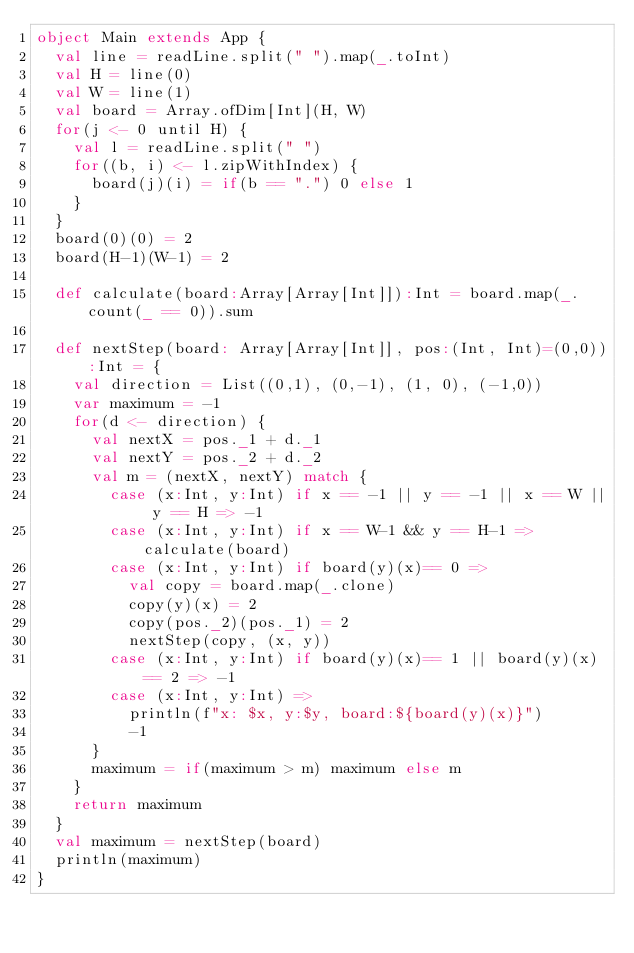<code> <loc_0><loc_0><loc_500><loc_500><_Scala_>object Main extends App {
  val line = readLine.split(" ").map(_.toInt)
  val H = line(0)
  val W = line(1)
  val board = Array.ofDim[Int](H, W)
  for(j <- 0 until H) {
    val l = readLine.split(" ")
    for((b, i) <- l.zipWithIndex) {
      board(j)(i) = if(b == ".") 0 else 1
    }
  }
  board(0)(0) = 2
  board(H-1)(W-1) = 2

  def calculate(board:Array[Array[Int]]):Int = board.map(_.count(_ == 0)).sum

  def nextStep(board: Array[Array[Int]], pos:(Int, Int)=(0,0)):Int = {
    val direction = List((0,1), (0,-1), (1, 0), (-1,0))
    var maximum = -1
    for(d <- direction) {
      val nextX = pos._1 + d._1
      val nextY = pos._2 + d._2
      val m = (nextX, nextY) match {
        case (x:Int, y:Int) if x == -1 || y == -1 || x == W || y == H => -1
        case (x:Int, y:Int) if x == W-1 && y == H-1 => calculate(board)
        case (x:Int, y:Int) if board(y)(x)== 0 =>
          val copy = board.map(_.clone)
          copy(y)(x) = 2
          copy(pos._2)(pos._1) = 2
          nextStep(copy, (x, y))
        case (x:Int, y:Int) if board(y)(x)== 1 || board(y)(x) == 2 => -1
        case (x:Int, y:Int) =>
          println(f"x: $x, y:$y, board:${board(y)(x)}")
          -1
      }
      maximum = if(maximum > m) maximum else m
    }
    return maximum
  }
  val maximum = nextStep(board)
  println(maximum)
}
</code> 